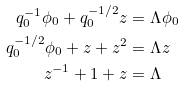Convert formula to latex. <formula><loc_0><loc_0><loc_500><loc_500>q _ { 0 } ^ { - 1 } \phi _ { 0 } + q _ { 0 } ^ { - 1 / 2 } z & = \Lambda \phi _ { 0 } \\ q _ { 0 } ^ { - 1 / 2 } \phi _ { 0 } + z + z ^ { 2 } & = \Lambda z \\ z ^ { - 1 } + 1 + z & = \Lambda</formula> 